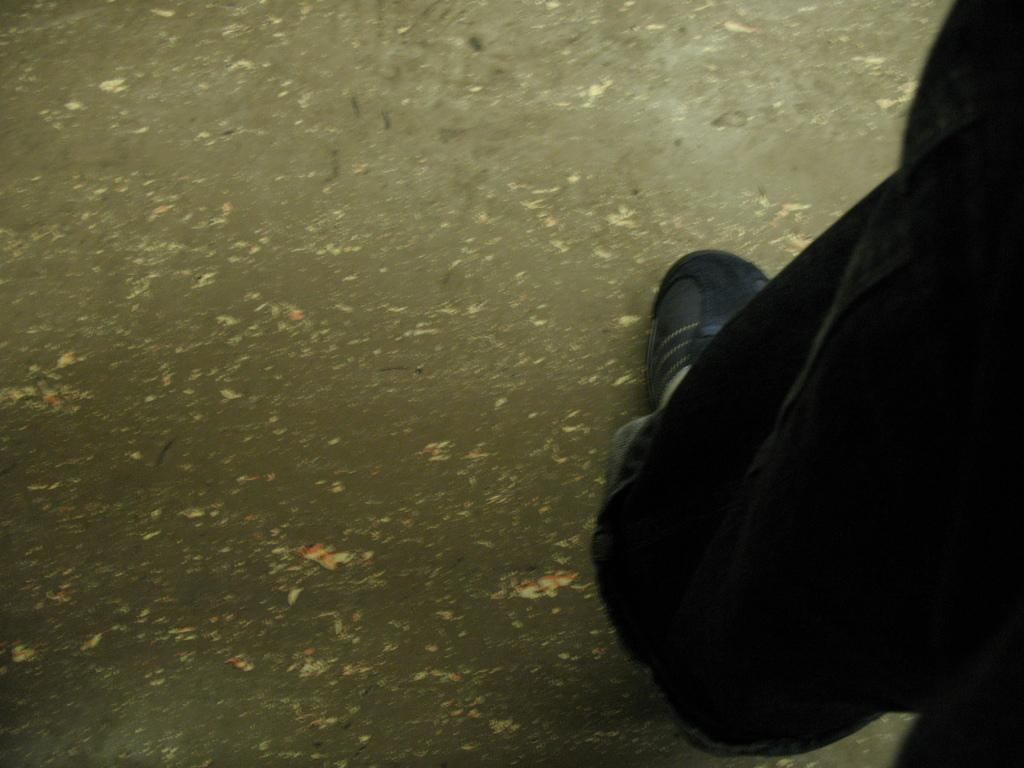What is located on the right side of the image? There is a person on the right side of the image. What can be observed about the person's footwear? The person is wearing black shoes. What type of reaction can be seen from the tin unit in the image? There is no tin unit present in the image, and therefore no reaction can be observed. 